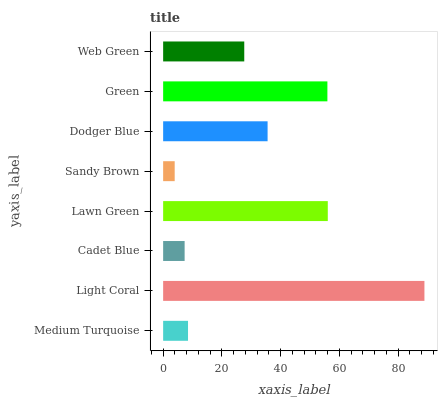Is Sandy Brown the minimum?
Answer yes or no. Yes. Is Light Coral the maximum?
Answer yes or no. Yes. Is Cadet Blue the minimum?
Answer yes or no. No. Is Cadet Blue the maximum?
Answer yes or no. No. Is Light Coral greater than Cadet Blue?
Answer yes or no. Yes. Is Cadet Blue less than Light Coral?
Answer yes or no. Yes. Is Cadet Blue greater than Light Coral?
Answer yes or no. No. Is Light Coral less than Cadet Blue?
Answer yes or no. No. Is Dodger Blue the high median?
Answer yes or no. Yes. Is Web Green the low median?
Answer yes or no. Yes. Is Cadet Blue the high median?
Answer yes or no. No. Is Dodger Blue the low median?
Answer yes or no. No. 